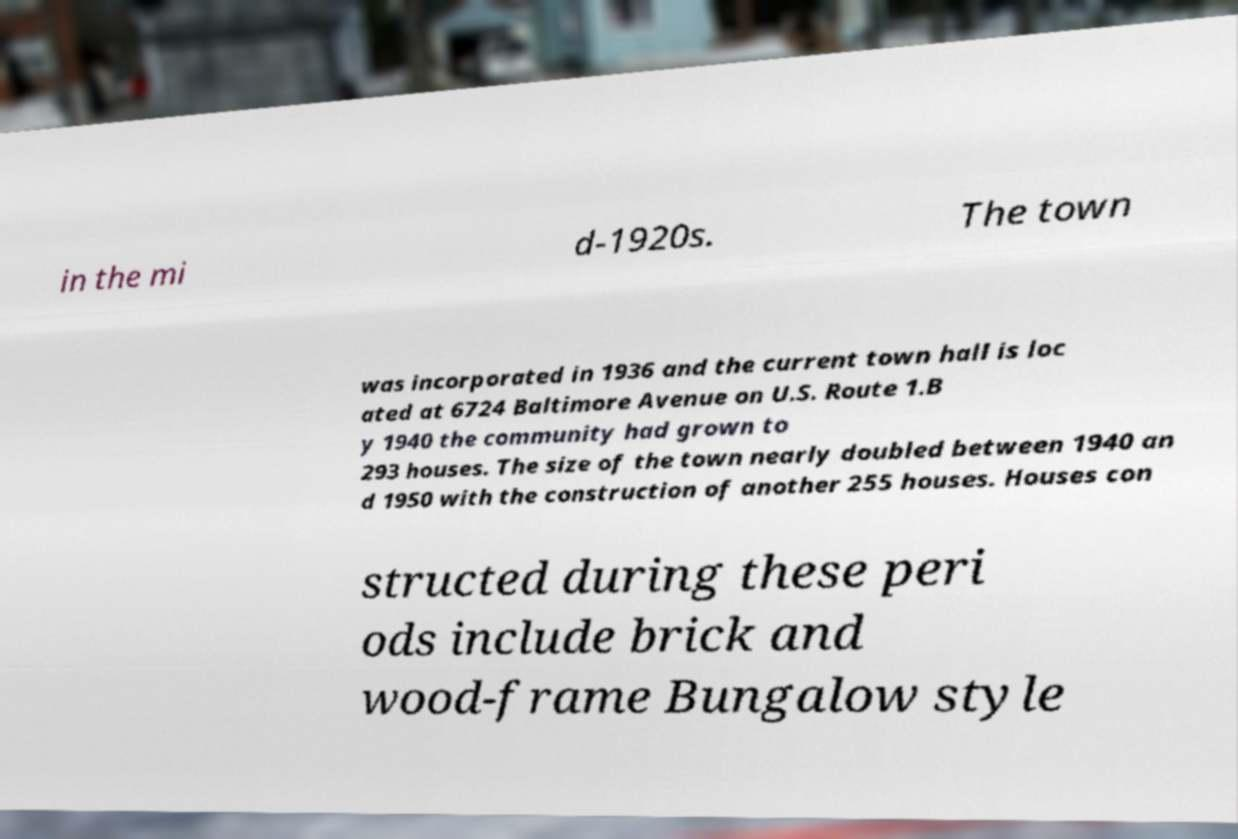For documentation purposes, I need the text within this image transcribed. Could you provide that? in the mi d-1920s. The town was incorporated in 1936 and the current town hall is loc ated at 6724 Baltimore Avenue on U.S. Route 1.B y 1940 the community had grown to 293 houses. The size of the town nearly doubled between 1940 an d 1950 with the construction of another 255 houses. Houses con structed during these peri ods include brick and wood-frame Bungalow style 